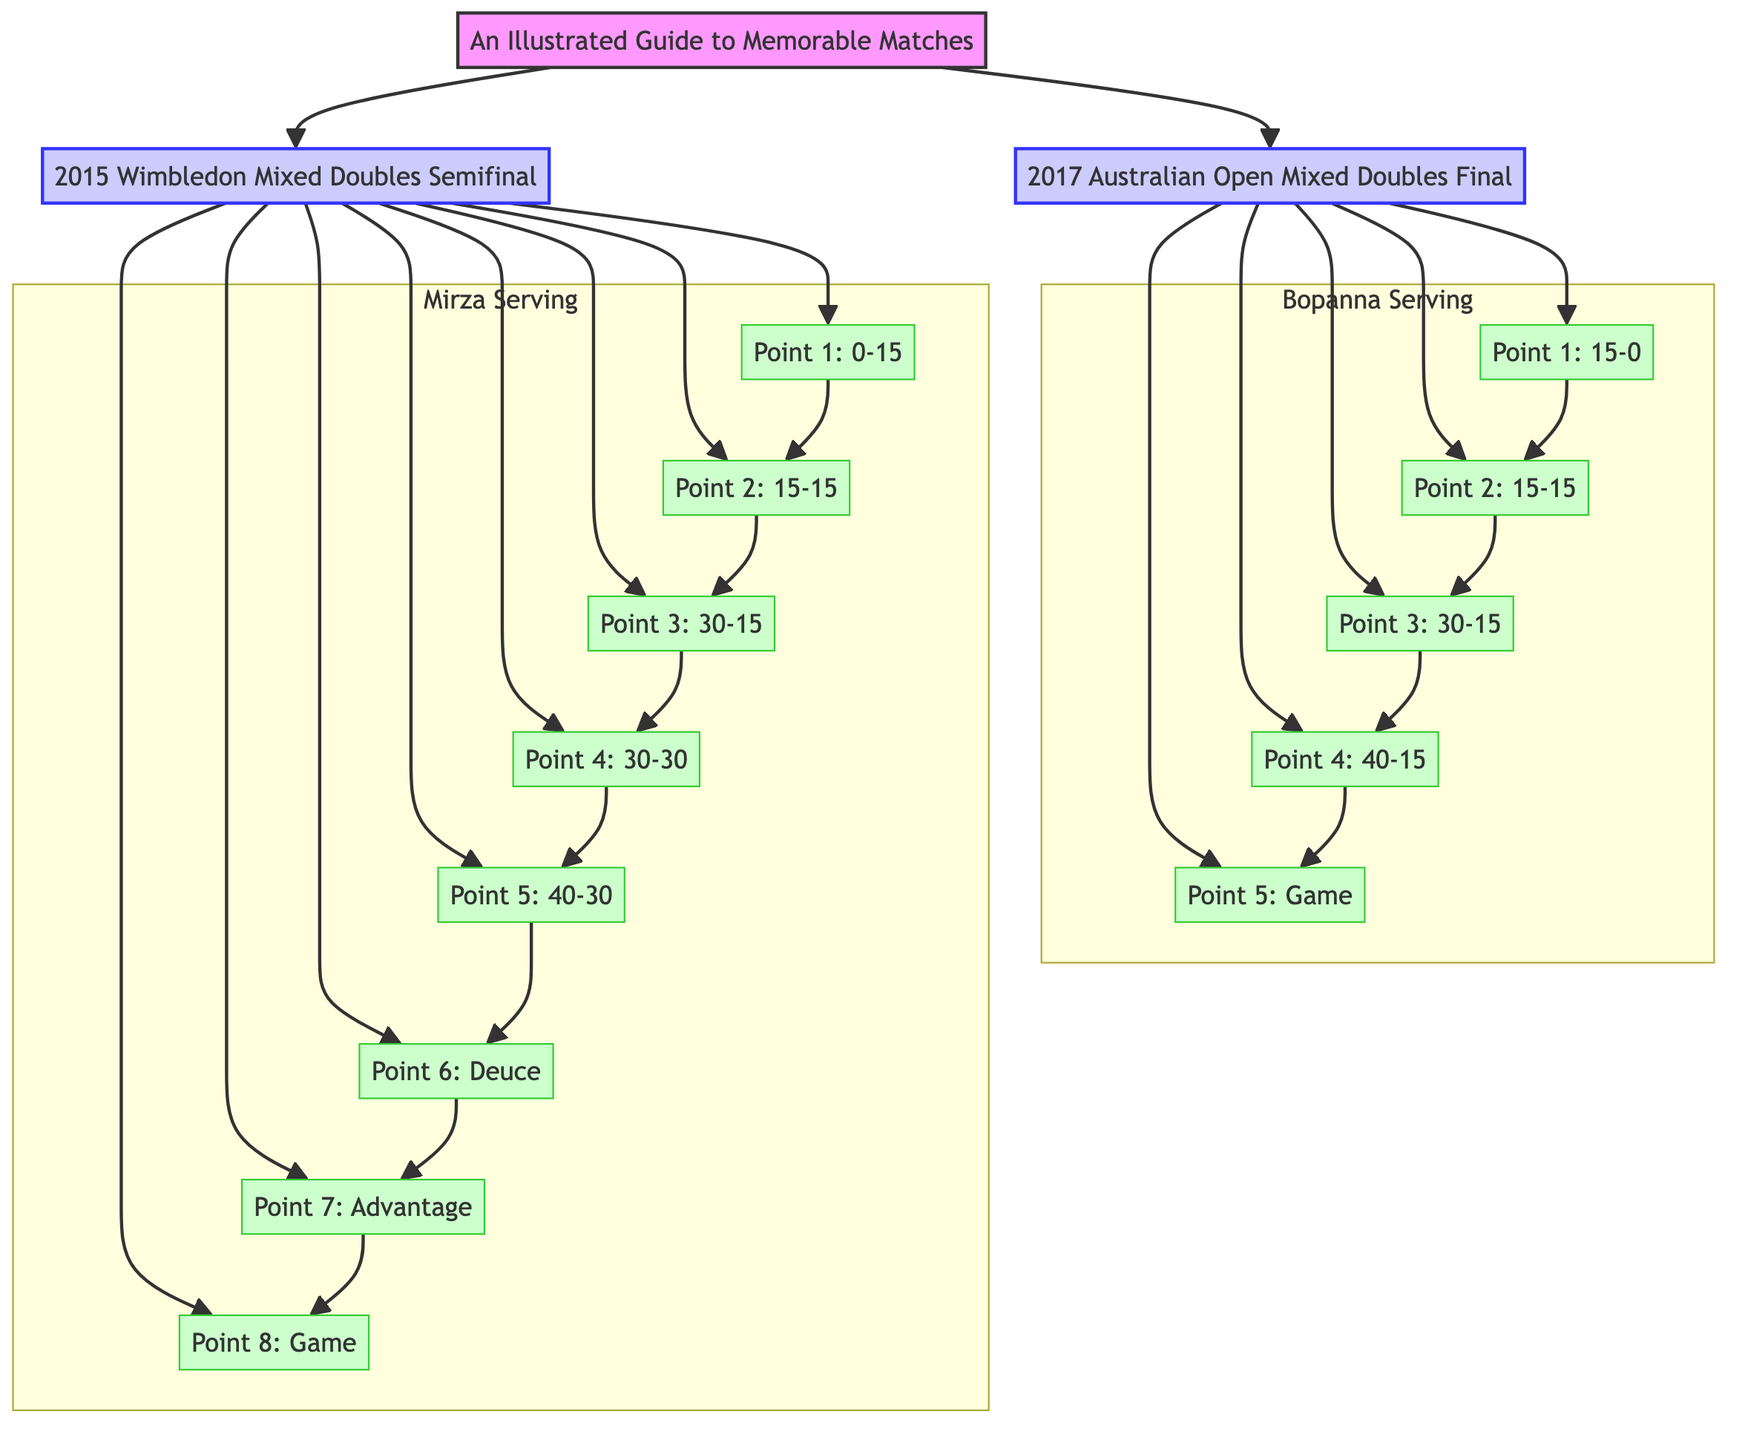What are the two memorable matches featured in the diagram? The diagram highlights two matches: "2017 Australian Open Mixed Doubles Final" and "2015 Wimbledon Mixed Doubles Semifinal". Both of these matches are nodes directly connected under the main node "An Illustrated Guide to Memorable Matches".
Answer: 2017 Australian Open Mixed Doubles Final, 2015 Wimbledon Mixed Doubles Semifinal Which point indicates the first score in the 2017 Australian Open Mixed Doubles Final? In the flow of the 2017 Australian Open match, the first point listed is "Point 1: 15-0", which represents the initial score in that match.
Answer: Point 1: 15-0 How many points are there in the 2015 Wimbledon Mixed Doubles Semifinal? The 2015 Wimbledon match includes a series of eight points ranging from the score "0-15" to "Game", making a total of 8 points.
Answer: 8 What happens after the point labeled "30-15" in the 2015 Wimbledon Mixed Doubles Semifinal? Following the point "30-15", the next sequence continues with "Point 4: 30-30", indicating that after "30-15", the score changes to 30-30.
Answer: Point 4: 30-30 In the 2017 Australian Open Mixed Doubles Final, which point indicates the game win? In the flow of the 2017 Australian Open match, the final point is labeled as "Point 5: Game", indicating the completion of the game and the victory for that game round.
Answer: Point 5: Game How many scoring points are noted for Bopanna's service game? Bopanna’s service game includes five scoring points, which are numbered from "Point 1: 15-0" to "Point 5: Game". These points detail the progression of the score during his serve.
Answer: 5 What is the score at the "Advantage" point in the 2015 Wimbledon Mixed Doubles Semifinal? The "Advantage" point occurs after reaching the "Deuce" point, hence it indicates a favorable score which follows "Point 6: Deuce". This means the score should be at least "40" in favor of one side at that moment, but the specific score is not given, making it implied.
Answer: Advantage Which match has a longer sequence of scoring points based on the diagram? The 2015 Wimbledon Mixed Doubles Semifinal, with 8 points, has a longer sequence of scoring points compared to the 2017 Australian Open match, which has only 5 points.
Answer: 2015 Wimbledon Mixed Doubles Semifinal 